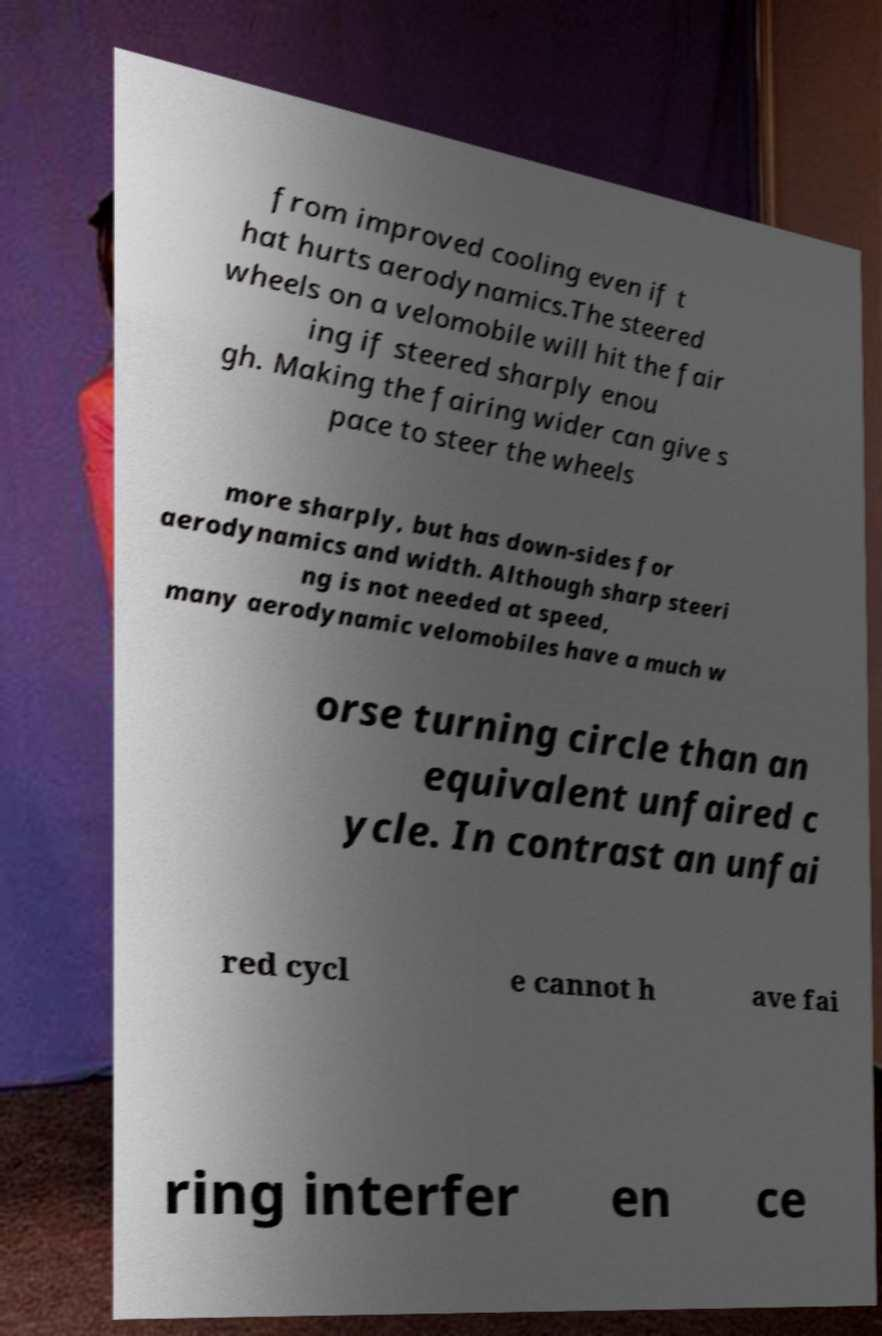Please read and relay the text visible in this image. What does it say? from improved cooling even if t hat hurts aerodynamics.The steered wheels on a velomobile will hit the fair ing if steered sharply enou gh. Making the fairing wider can give s pace to steer the wheels more sharply, but has down-sides for aerodynamics and width. Although sharp steeri ng is not needed at speed, many aerodynamic velomobiles have a much w orse turning circle than an equivalent unfaired c ycle. In contrast an unfai red cycl e cannot h ave fai ring interfer en ce 